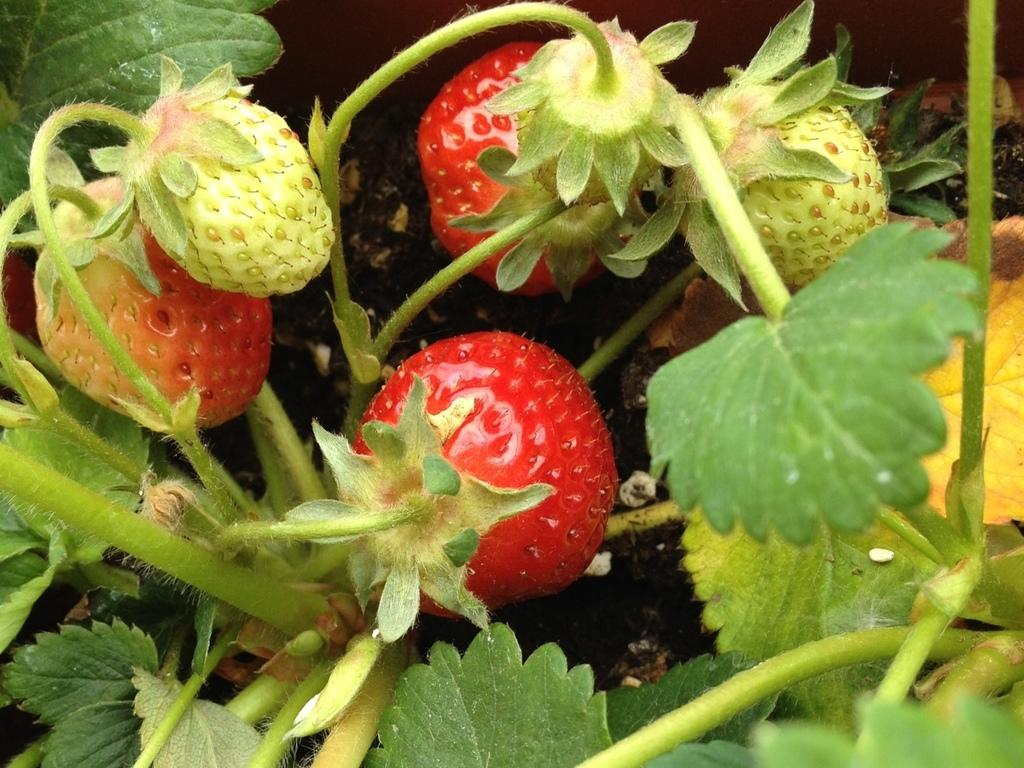What type of fruit can be seen in the image? There are strawberries in the image. What else is present in the image besides the strawberries? There are leaves visible in the image. What can be seen in the background of the image? Soil is visible in the background of the image. Can you hear a bat whistling in the image? There is no bat or whistling sound present in the image. 